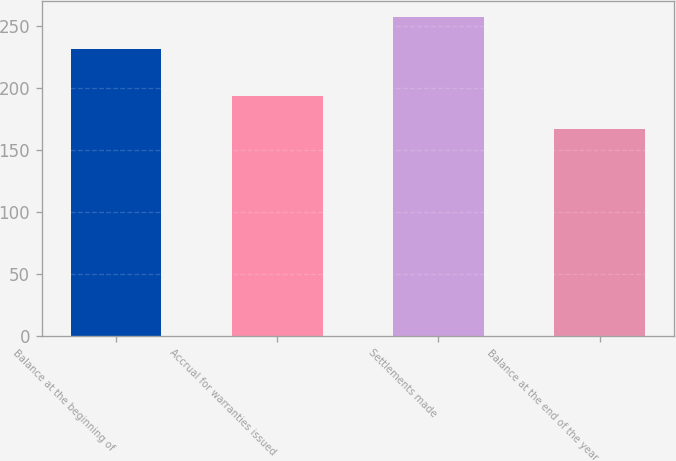Convert chart. <chart><loc_0><loc_0><loc_500><loc_500><bar_chart><fcel>Balance at the beginning of<fcel>Accrual for warranties issued<fcel>Settlements made<fcel>Balance at the end of the year<nl><fcel>231<fcel>193<fcel>257<fcel>167<nl></chart> 